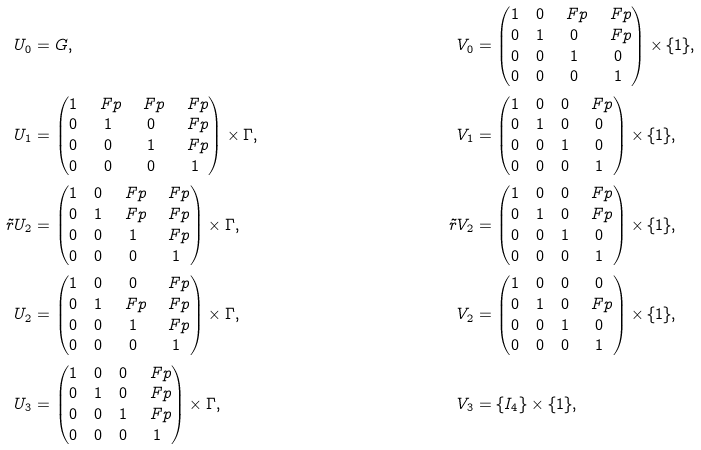Convert formula to latex. <formula><loc_0><loc_0><loc_500><loc_500>U _ { 0 } & = G , & V _ { 0 } & = \begin{pmatrix} 1 & 0 & \ F p & \ F p \\ 0 & 1 & 0 & \ F p \\ 0 & 0 & 1 & 0 \\ 0 & 0 & 0 & 1 \end{pmatrix} \times \{ 1 \} , \\ U _ { 1 } & = \begin{pmatrix} 1 & \ F p & \ F p & \ F p \\ 0 & 1 & 0 & \ F p \\ 0 & 0 & 1 & \ F p \\ 0 & 0 & 0 & 1 \end{pmatrix} \times \Gamma , & V _ { 1 } & = \begin{pmatrix} 1 & 0 & 0 & \ F p \\ 0 & 1 & 0 & 0 \\ 0 & 0 & 1 & 0 \\ 0 & 0 & 0 & 1 \end{pmatrix} \times \{ 1 \} , \\ \tilde { r } { U _ { 2 } } & = \begin{pmatrix} 1 & 0 & \ F p & \ F p \\ 0 & 1 & \ F p & \ F p \\ 0 & 0 & 1 & \ F p \\ 0 & 0 & 0 & 1 \end{pmatrix} \times \Gamma , & \tilde { r } { V _ { 2 } } & = \begin{pmatrix} 1 & 0 & 0 & \ F p \\ 0 & 1 & 0 & \ F p \\ 0 & 0 & 1 & 0 \\ 0 & 0 & 0 & 1 \end{pmatrix} \times \{ 1 \} , \\ U _ { 2 } & = \begin{pmatrix} 1 & 0 & 0 & \ F p \\ 0 & 1 & \ F p & \ F p \\ 0 & 0 & 1 & \ F p \\ 0 & 0 & 0 & 1 \end{pmatrix} \times \Gamma , & V _ { 2 } & = \begin{pmatrix} 1 & 0 & 0 & 0 \\ 0 & 1 & 0 & \ F p \\ 0 & 0 & 1 & 0 \\ 0 & 0 & 0 & 1 \end{pmatrix} \times \{ 1 \} , \\ U _ { 3 } & = \begin{pmatrix} 1 & 0 & 0 & \ F p \\ 0 & 1 & 0 & \ F p \\ 0 & 0 & 1 & \ F p \\ 0 & 0 & 0 & 1 \end{pmatrix} \times \Gamma , & V _ { 3 } & = \{ I _ { 4 } \} \times \{ 1 \} ,</formula> 